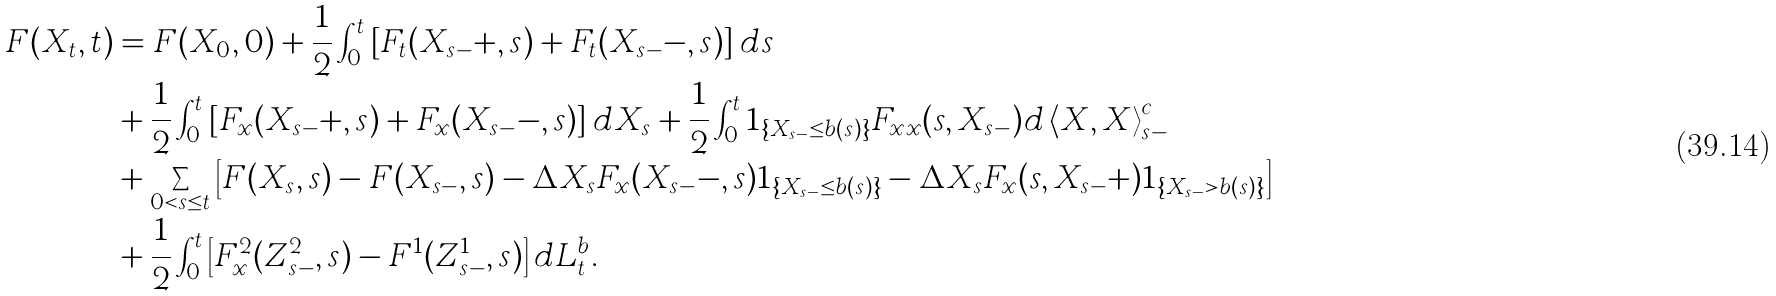Convert formula to latex. <formula><loc_0><loc_0><loc_500><loc_500>F ( X _ { t } , t ) & = F ( X _ { 0 } , 0 ) + \frac { 1 } { 2 } \int _ { 0 } ^ { t } \left [ F _ { t } ( X _ { s - } + , s ) + F _ { t } ( X _ { s - } - , s ) \right ] d s \\ & + \frac { 1 } { 2 } \int _ { 0 } ^ { t } \left [ F _ { x } ( X _ { s - } + , s ) + F _ { x } ( X _ { s - } - , s ) \right ] d X _ { s } + \frac { 1 } { 2 } \int _ { 0 } ^ { t } 1 _ { \{ X _ { s - } \leq b ( s ) \} } F _ { x x } ( s , X _ { s - } ) d \left < X , X \right > ^ { c } _ { s - } \\ & + \sum _ { 0 < s \leq t } \left [ F ( X _ { s } , s ) - F ( X _ { s - } , s ) - \Delta X _ { s } F _ { x } ( X _ { s - } - , s ) 1 _ { \{ X _ { s - } \leq b ( s ) \} } - \Delta X _ { s } F _ { x } ( s , X _ { s - } + ) 1 _ { \{ X _ { s - } > b ( s ) \} } \right ] \\ & + \frac { 1 } { 2 } \int _ { 0 } ^ { t } \left [ F _ { x } ^ { 2 } ( Z ^ { 2 } _ { s - } , s ) - F ^ { 1 } ( Z ^ { 1 } _ { s - } , s ) \right ] d L _ { t } ^ { b } .</formula> 